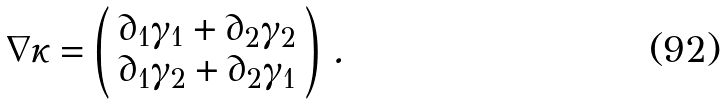Convert formula to latex. <formula><loc_0><loc_0><loc_500><loc_500>\nabla \kappa = \left ( \begin{array} { c } \partial _ { 1 } \gamma _ { 1 } + \partial _ { 2 } \gamma _ { 2 } \\ \partial _ { 1 } \gamma _ { 2 } + \partial _ { 2 } \gamma _ { 1 } \end{array} \right ) \, .</formula> 